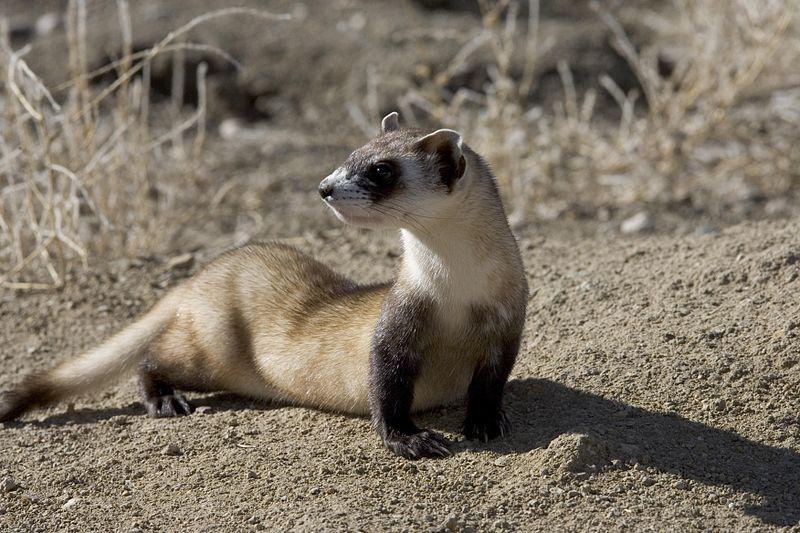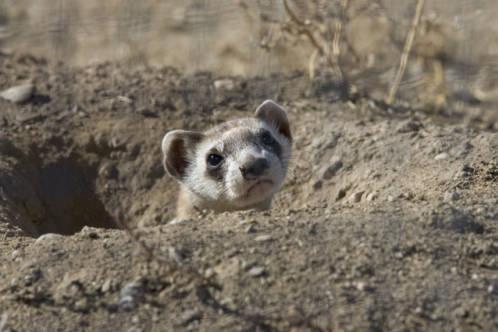The first image is the image on the left, the second image is the image on the right. Examine the images to the left and right. Is the description "There are two animals in total." accurate? Answer yes or no. Yes. The first image is the image on the left, the second image is the image on the right. Given the left and right images, does the statement "An image shows exactly one ferret partly emerged from a hole in the ground, with no manmade material visible." hold true? Answer yes or no. Yes. 